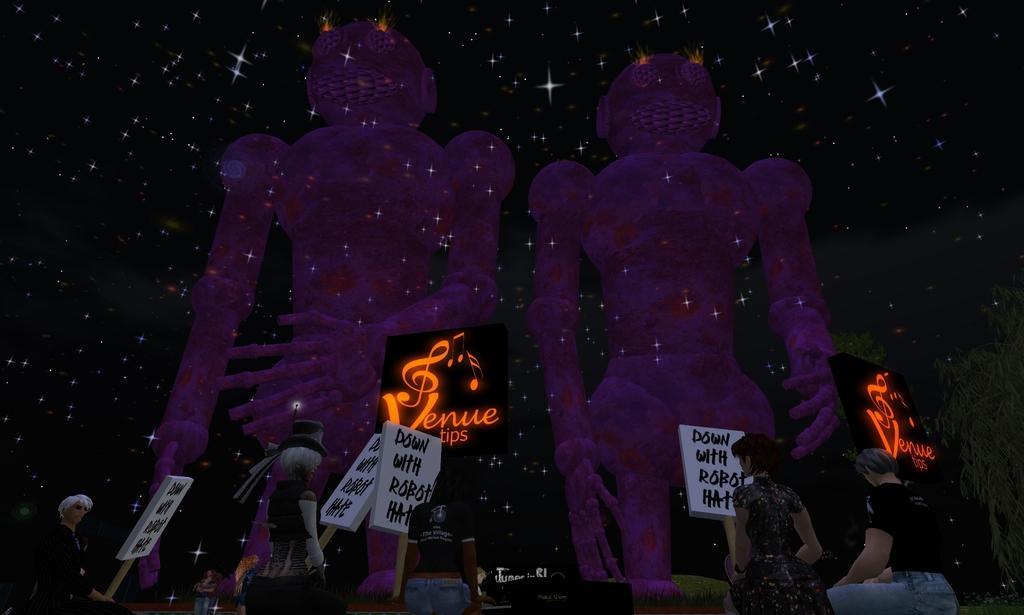Describe this image in one or two sentences. In this image I can see depiction picture where I can see people, few boards, stars, few trees and on these boards I can see something is written. 